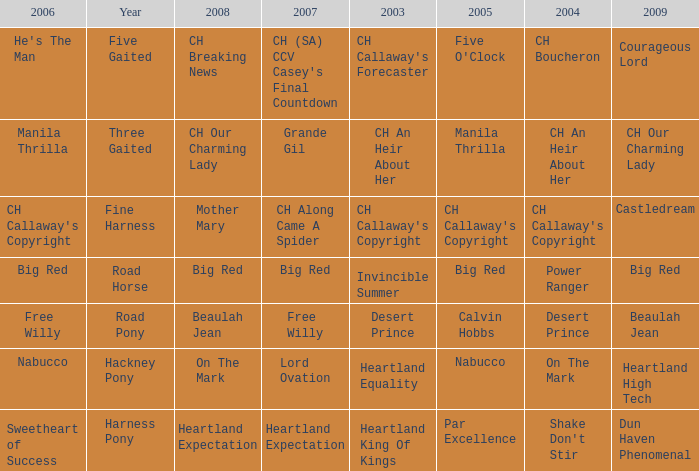What is the 2008 for the 2009 ch our charming lady? CH Our Charming Lady. 